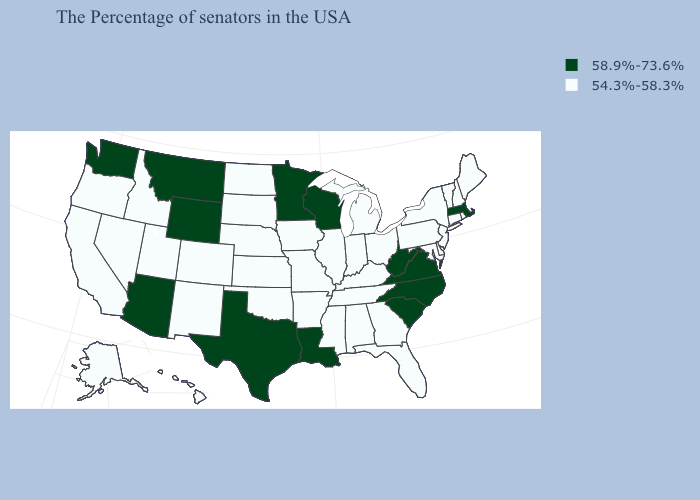Name the states that have a value in the range 54.3%-58.3%?
Give a very brief answer. Maine, Rhode Island, New Hampshire, Vermont, Connecticut, New York, New Jersey, Delaware, Maryland, Pennsylvania, Ohio, Florida, Georgia, Michigan, Kentucky, Indiana, Alabama, Tennessee, Illinois, Mississippi, Missouri, Arkansas, Iowa, Kansas, Nebraska, Oklahoma, South Dakota, North Dakota, Colorado, New Mexico, Utah, Idaho, Nevada, California, Oregon, Alaska, Hawaii. What is the highest value in the USA?
Keep it brief. 58.9%-73.6%. What is the lowest value in the West?
Give a very brief answer. 54.3%-58.3%. Name the states that have a value in the range 54.3%-58.3%?
Write a very short answer. Maine, Rhode Island, New Hampshire, Vermont, Connecticut, New York, New Jersey, Delaware, Maryland, Pennsylvania, Ohio, Florida, Georgia, Michigan, Kentucky, Indiana, Alabama, Tennessee, Illinois, Mississippi, Missouri, Arkansas, Iowa, Kansas, Nebraska, Oklahoma, South Dakota, North Dakota, Colorado, New Mexico, Utah, Idaho, Nevada, California, Oregon, Alaska, Hawaii. Does Tennessee have a lower value than Virginia?
Give a very brief answer. Yes. Does the map have missing data?
Give a very brief answer. No. Does the first symbol in the legend represent the smallest category?
Answer briefly. No. What is the value of Georgia?
Give a very brief answer. 54.3%-58.3%. Name the states that have a value in the range 54.3%-58.3%?
Concise answer only. Maine, Rhode Island, New Hampshire, Vermont, Connecticut, New York, New Jersey, Delaware, Maryland, Pennsylvania, Ohio, Florida, Georgia, Michigan, Kentucky, Indiana, Alabama, Tennessee, Illinois, Mississippi, Missouri, Arkansas, Iowa, Kansas, Nebraska, Oklahoma, South Dakota, North Dakota, Colorado, New Mexico, Utah, Idaho, Nevada, California, Oregon, Alaska, Hawaii. How many symbols are there in the legend?
Write a very short answer. 2. What is the value of Colorado?
Write a very short answer. 54.3%-58.3%. What is the value of Texas?
Be succinct. 58.9%-73.6%. Among the states that border Georgia , does South Carolina have the lowest value?
Answer briefly. No. 